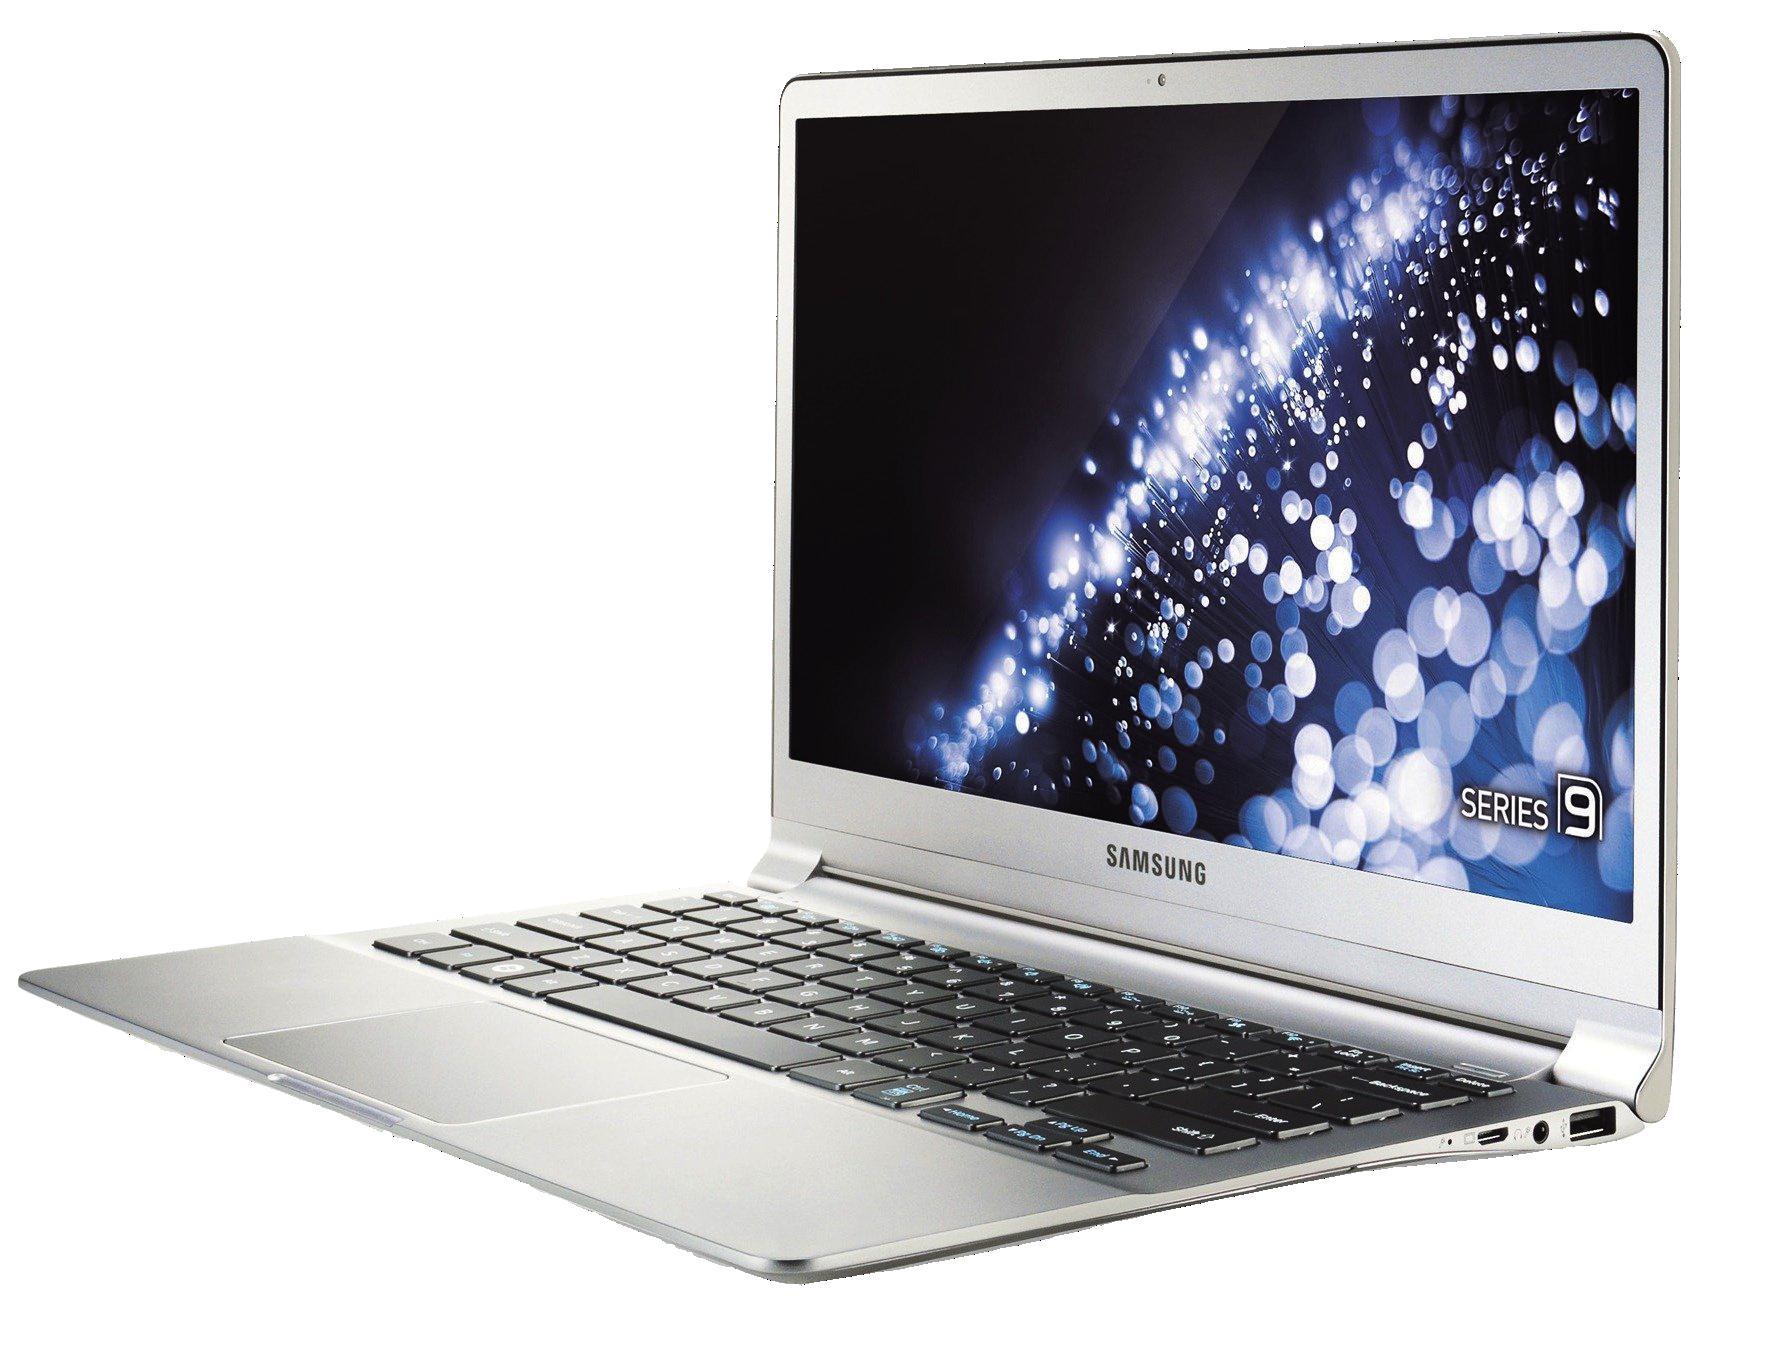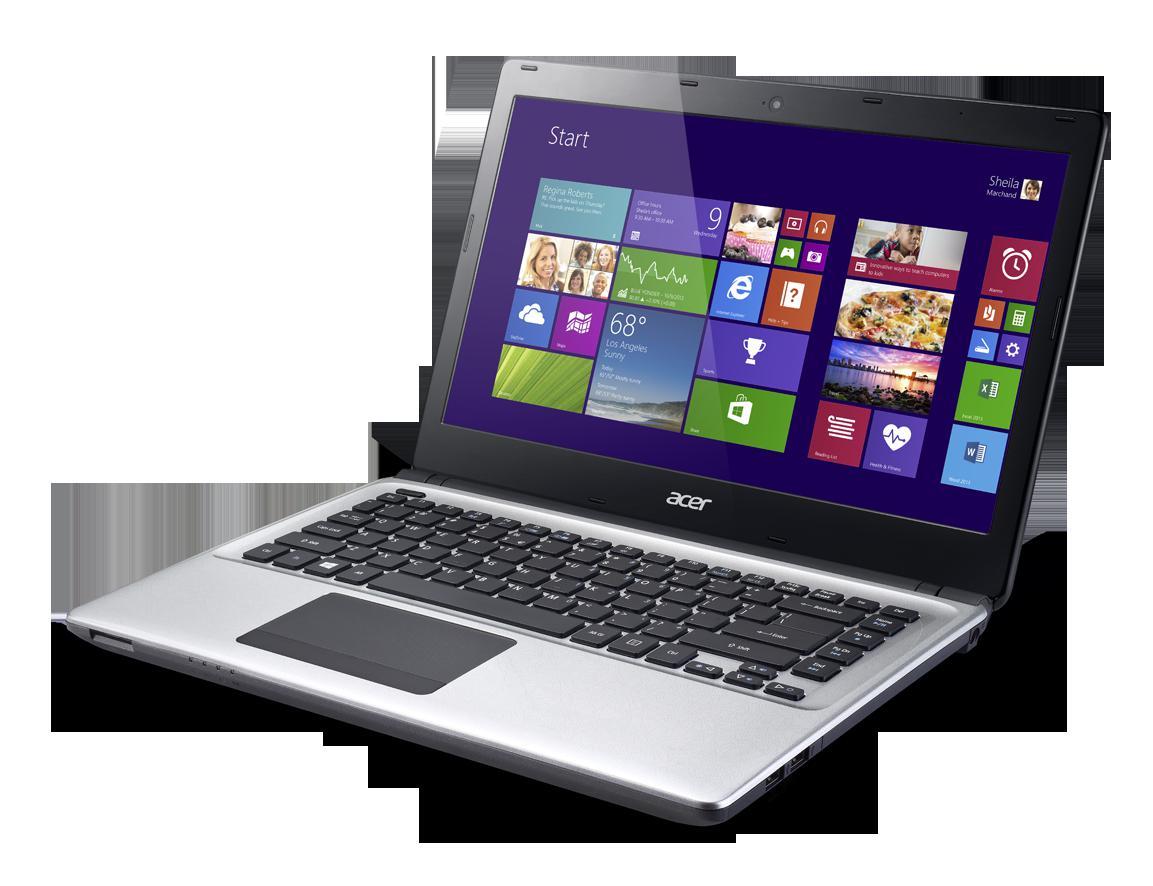The first image is the image on the left, the second image is the image on the right. Considering the images on both sides, is "The right image depicts three laptops." valid? Answer yes or no. No. The first image is the image on the left, the second image is the image on the right. For the images shown, is this caption "The right image features three opened laptops." true? Answer yes or no. No. 